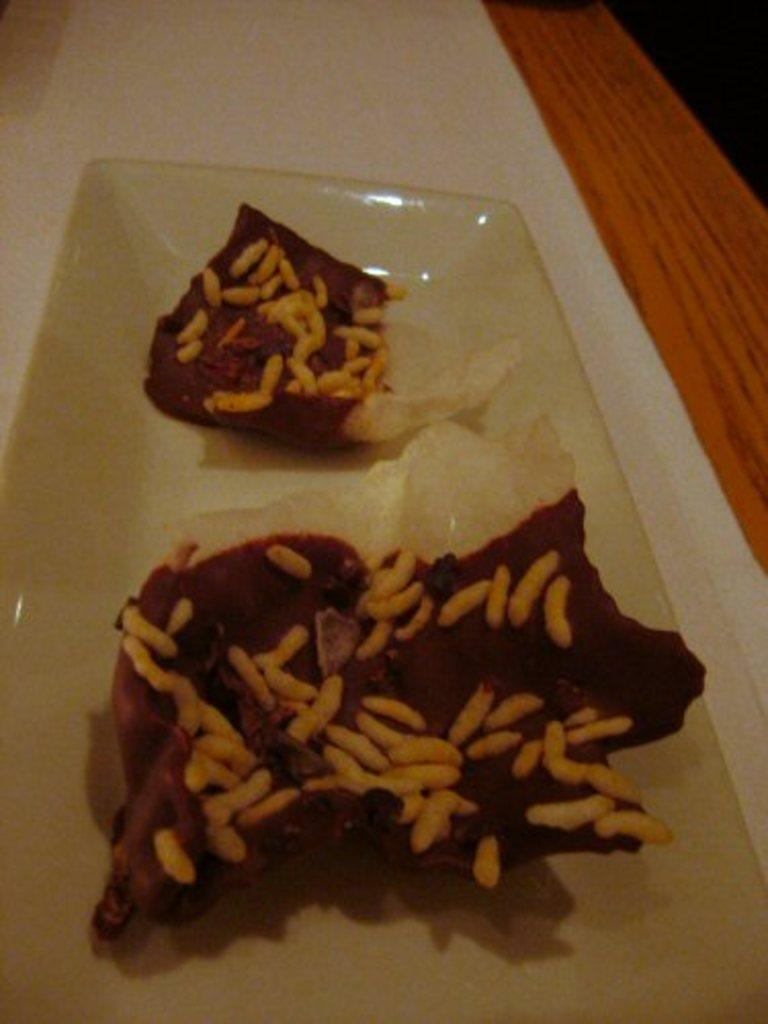What is on the plate in the image? There is a food item on a plate in the image. What type of table is visible in the image? There is a wooden table in the image. What disease is the food item on the plate trying to cure in the image? There is no indication of a disease or any medical context in the image. The image simply shows a food item on a plate and a wooden table. 